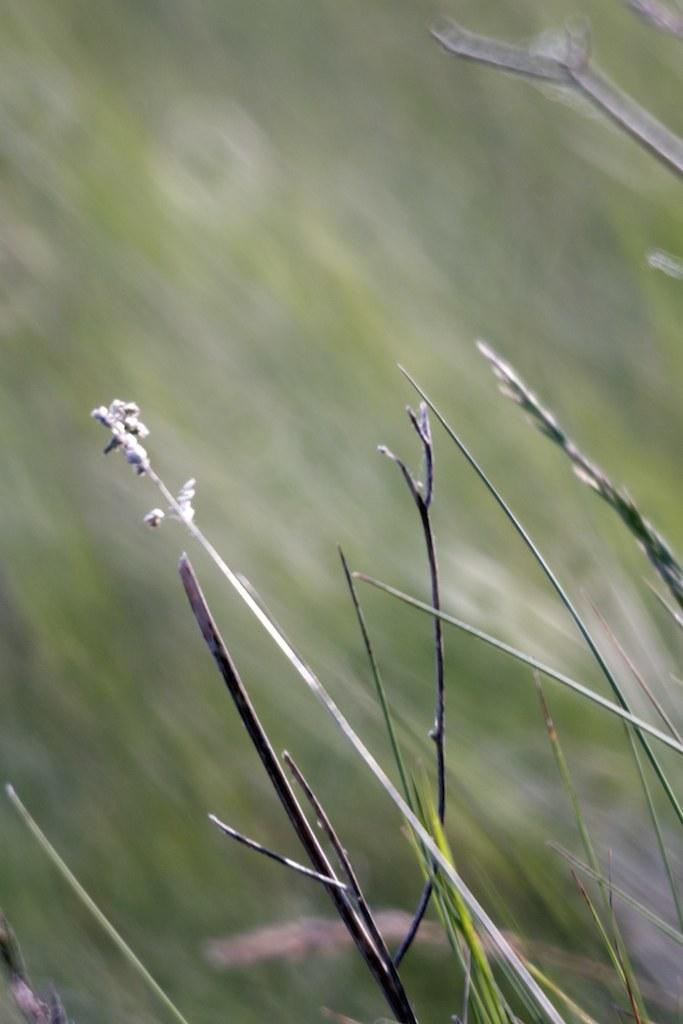What type of living organisms can be seen in the image? Plants can be seen in the image. Can you describe the background of the image? The background of the image is blurry. What type of loss is depicted in the scene in the image? There is no scene or loss depicted in the image; it only features plants and a blurry background. 